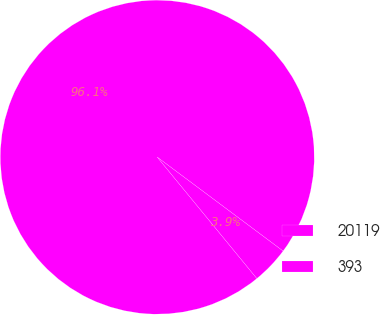<chart> <loc_0><loc_0><loc_500><loc_500><pie_chart><fcel>20119<fcel>393<nl><fcel>96.14%<fcel>3.86%<nl></chart> 